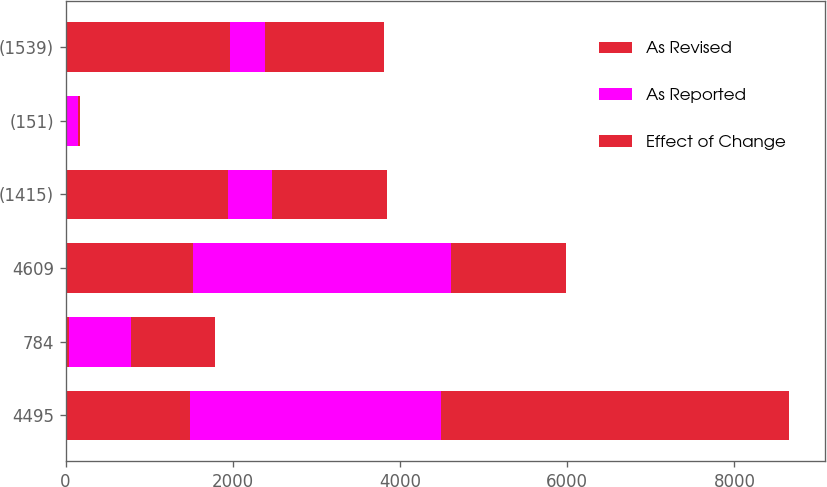Convert chart to OTSL. <chart><loc_0><loc_0><loc_500><loc_500><stacked_bar_chart><ecel><fcel>4495<fcel>784<fcel>4609<fcel>(1415)<fcel>(151)<fcel>(1539)<nl><fcel>As Revised<fcel>1483<fcel>42<fcel>1525<fcel>1942<fcel>22<fcel>1964<nl><fcel>As Reported<fcel>3012<fcel>742<fcel>3084<fcel>527<fcel>129<fcel>425<nl><fcel>Effect of Change<fcel>4159<fcel>1006<fcel>1380<fcel>1380<fcel>19<fcel>1415<nl></chart> 